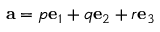<formula> <loc_0><loc_0><loc_500><loc_500>a = p e _ { 1 } + q e _ { 2 } + r e _ { 3 }</formula> 